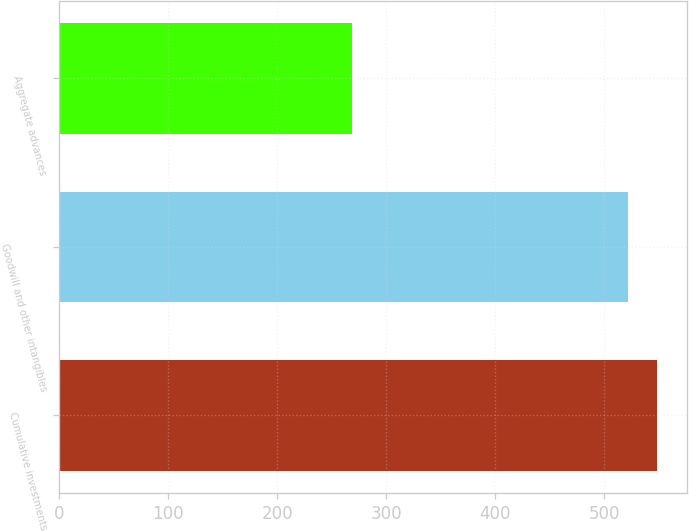<chart> <loc_0><loc_0><loc_500><loc_500><bar_chart><fcel>Cumulative investments<fcel>Goodwill and other intangibles<fcel>Aggregate advances<nl><fcel>548.19<fcel>522.1<fcel>268.1<nl></chart> 